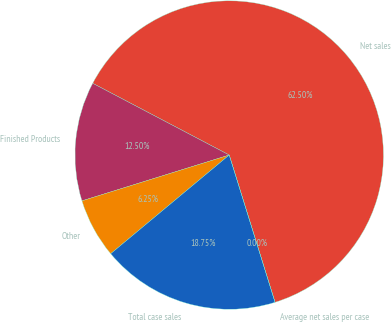<chart> <loc_0><loc_0><loc_500><loc_500><pie_chart><fcel>Net sales<fcel>Finished Products<fcel>Other<fcel>Total case sales<fcel>Average net sales per case<nl><fcel>62.5%<fcel>12.5%<fcel>6.25%<fcel>18.75%<fcel>0.0%<nl></chart> 